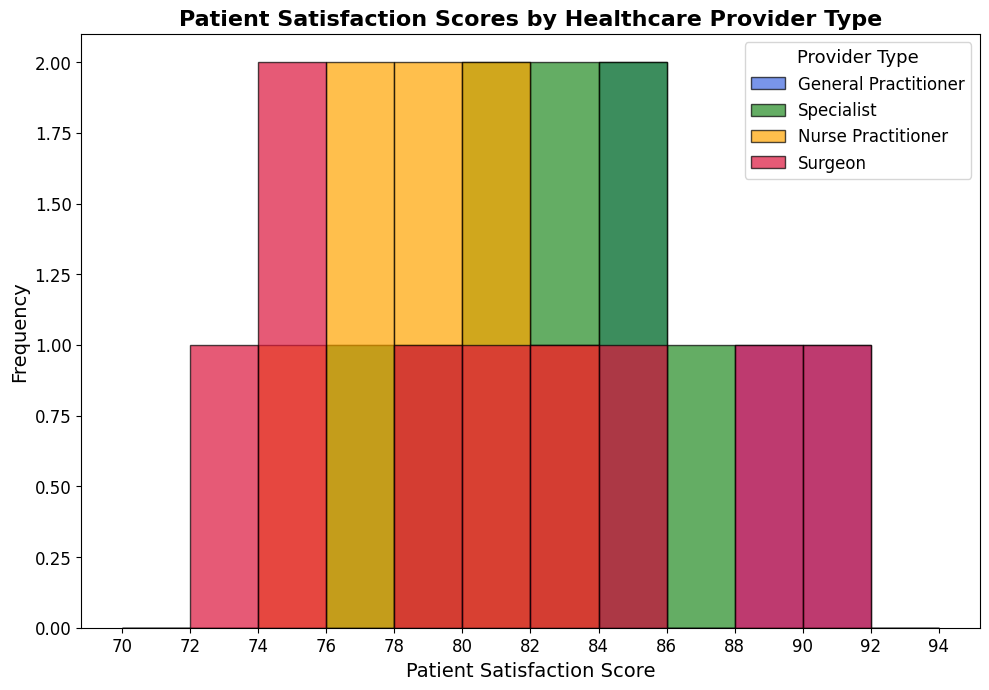What is the most common patient satisfaction score range for General Practitioners based on the histogram? Looking at the histogram, identify the range (bin) that has the highest frequency of scores for General Practitioners. The highest bin is between 84 and 86.
Answer: 84-86 Which healthcare provider type has the highest patient satisfaction scores overall? Compare the highest bins across all healthcare provider types. Surgeons have the scores reaching up to 90.
Answer: Surgeons How does the frequency of patient satisfaction scores for Nurse Practitioners in the range 78-80 compare to that of Specialists in the same range? Check the height of the bins in the 78-80 range for both Nurse Practitioners and Specialists. Nurse Practitioners have higher frequency in this range.
Answer: Higher for Nurse Practitioners What is the average range of patient satisfaction scores for Specialists? Observe the span of scores for Specialists from the histogram. Specialists span scores from 77-86.
Answer: 77-86 Which healthcare provider type shows the least variation in patient satisfaction scores? Identify the provider type with the narrowest span of scores. Nurse Practitioners have the least variation (75-82).
Answer: Nurse Practitioners Among all healthcare provider types, which one has the lowest recorded patient satisfaction score? Find the lowest-bin scores across all provider types. The lowest score is 72 for Surgeons.
Answer: Surgeons What is the modal score range for Specialists? Identify the score range with the highest frequency for Specialists. The highest frequency bin for Specialists is 84-86.
Answer: 84-86 Do General Practitioners or Surgeons have a wider range of patient satisfaction scores? Compare the range of scores for General Practitioners and Surgeons. General Practitioners range 76-90, Surgeons range 72-90.
Answer: Surgeons How does the frequency of the 80-82 score range for General Practitioners compare to that of Nurse Practitioners? Compare the height of bins for the 80-82 range between General Practitioners and Nurse Practitioners. General Practitioners have a higher frequency in this range.
Answer: Higher for General Practitioners 